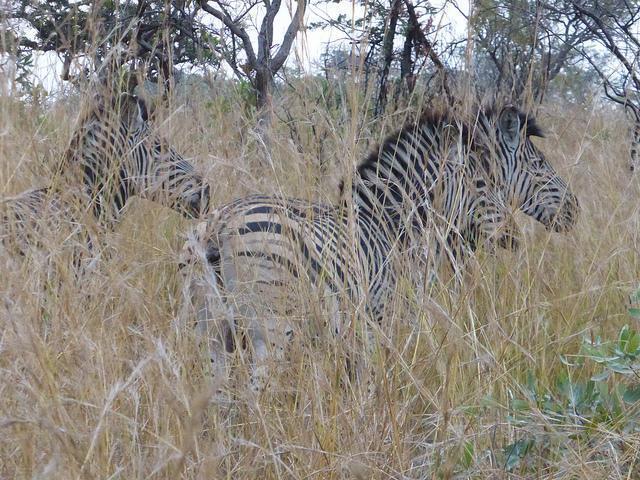How many animals are there?
Give a very brief answer. 3. How many legs do the striped animals have all together?
Give a very brief answer. 12. How many zebras is in the picture?
Give a very brief answer. 3. How many zebras are there?
Give a very brief answer. 3. 